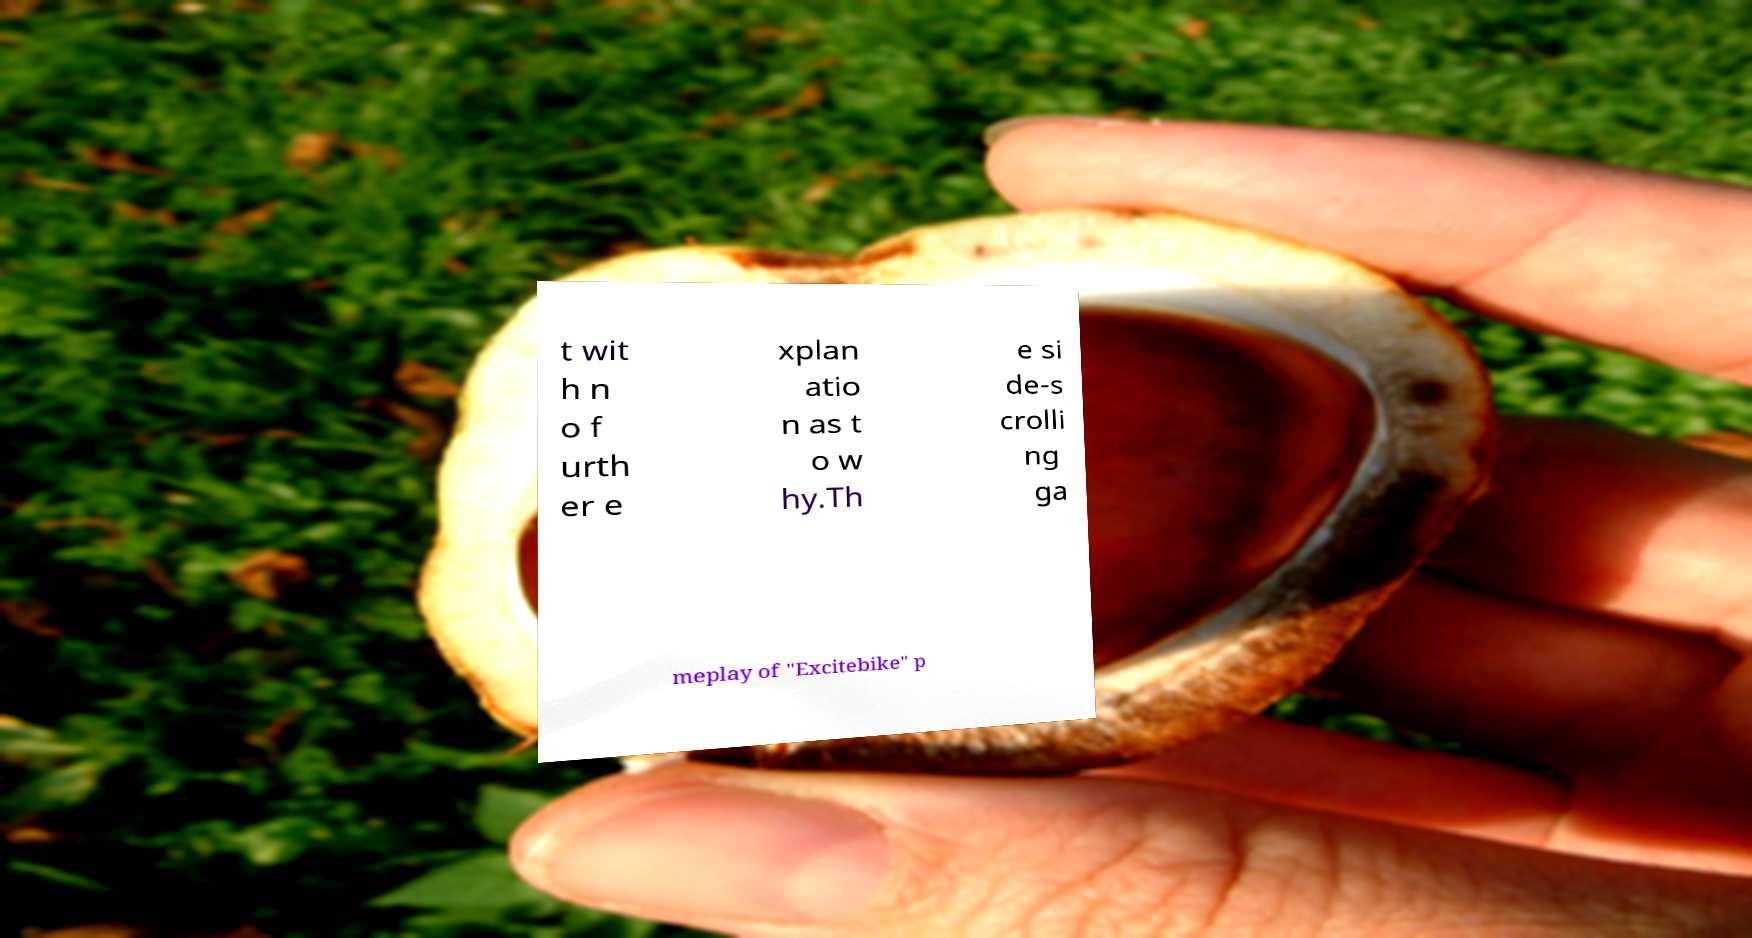For documentation purposes, I need the text within this image transcribed. Could you provide that? t wit h n o f urth er e xplan atio n as t o w hy.Th e si de-s crolli ng ga meplay of "Excitebike" p 